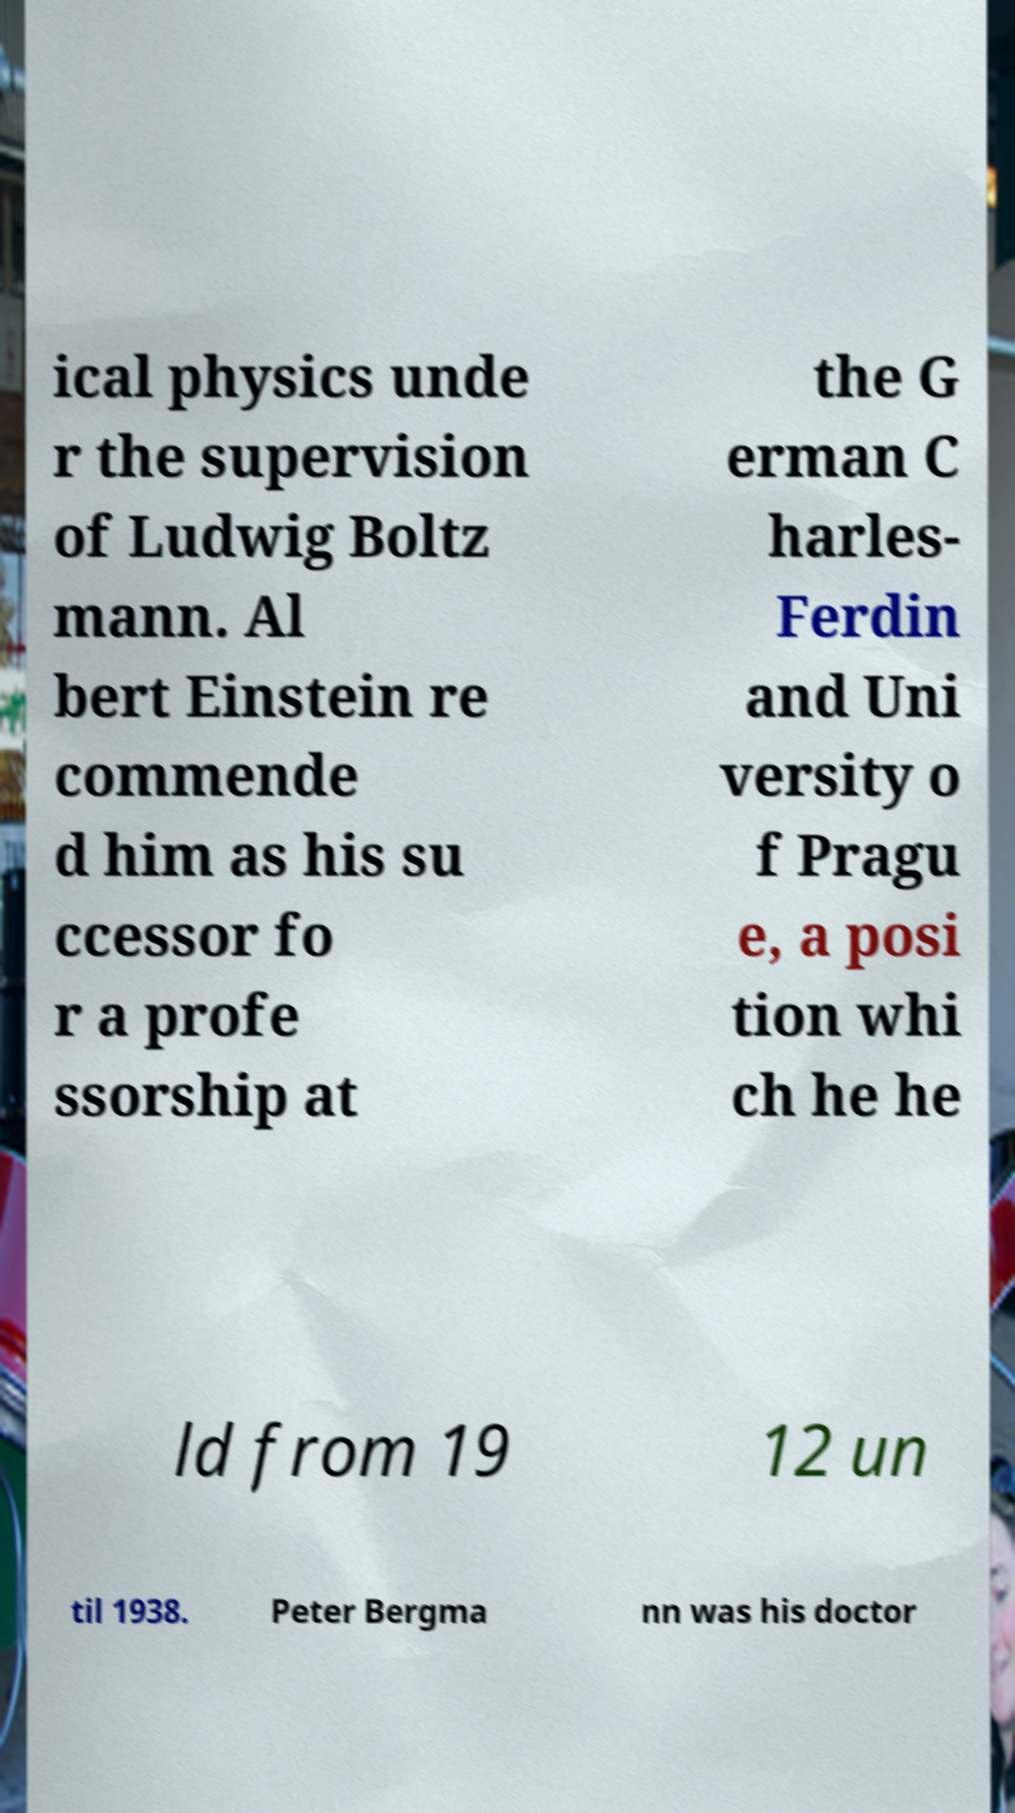Could you assist in decoding the text presented in this image and type it out clearly? ical physics unde r the supervision of Ludwig Boltz mann. Al bert Einstein re commende d him as his su ccessor fo r a profe ssorship at the G erman C harles- Ferdin and Uni versity o f Pragu e, a posi tion whi ch he he ld from 19 12 un til 1938. Peter Bergma nn was his doctor 